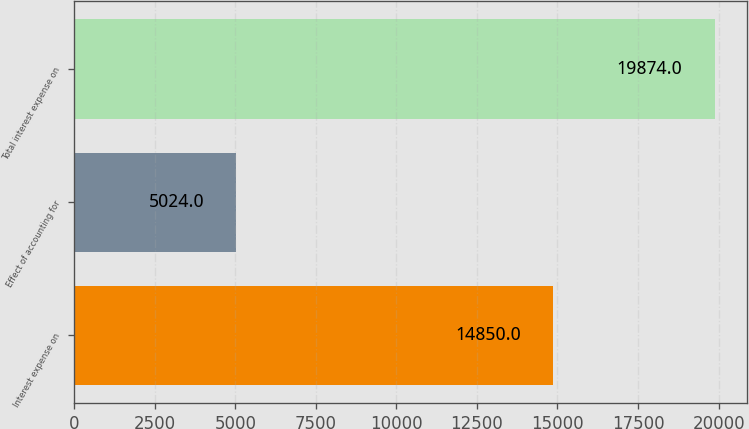<chart> <loc_0><loc_0><loc_500><loc_500><bar_chart><fcel>Interest expense on<fcel>Effect of accounting for<fcel>Total interest expense on<nl><fcel>14850<fcel>5024<fcel>19874<nl></chart> 